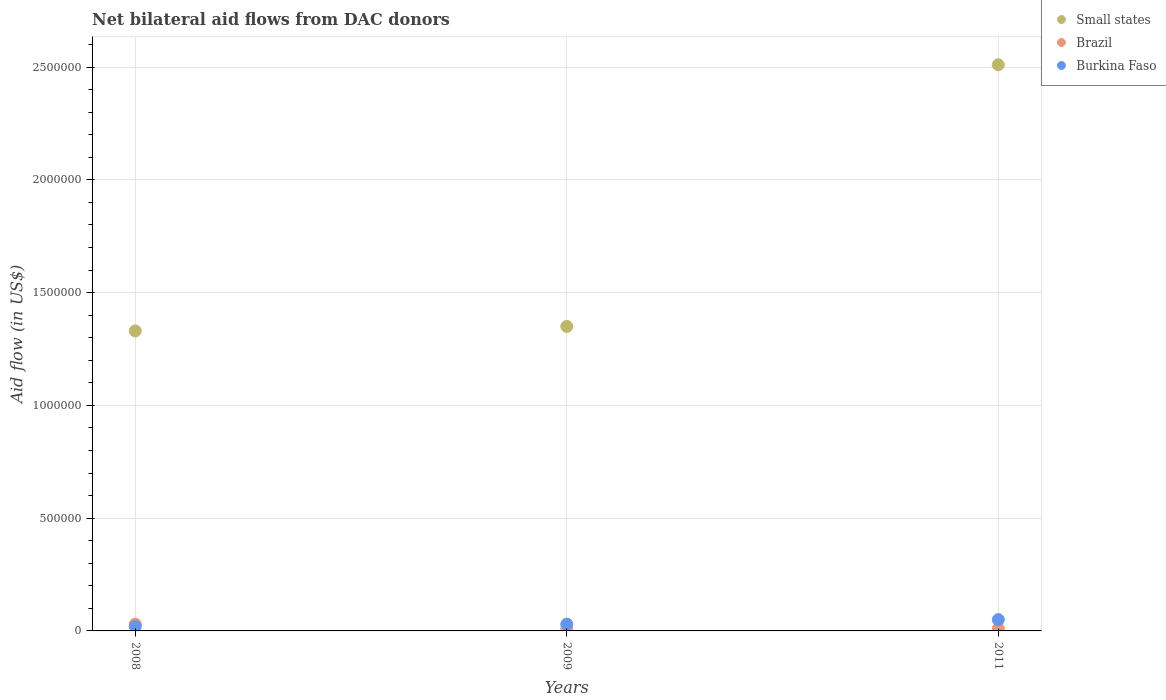Is the number of dotlines equal to the number of legend labels?
Your answer should be compact. Yes. What is the average net bilateral aid flow in Burkina Faso per year?
Your response must be concise. 3.33e+04. In the year 2011, what is the difference between the net bilateral aid flow in Burkina Faso and net bilateral aid flow in Brazil?
Your answer should be very brief. 4.00e+04. In how many years, is the net bilateral aid flow in Brazil greater than 1400000 US$?
Provide a succinct answer. 0. What is the difference between the highest and the lowest net bilateral aid flow in Burkina Faso?
Your answer should be compact. 3.00e+04. Is the sum of the net bilateral aid flow in Burkina Faso in 2008 and 2009 greater than the maximum net bilateral aid flow in Brazil across all years?
Keep it short and to the point. Yes. Is it the case that in every year, the sum of the net bilateral aid flow in Small states and net bilateral aid flow in Burkina Faso  is greater than the net bilateral aid flow in Brazil?
Provide a short and direct response. Yes. Is the net bilateral aid flow in Burkina Faso strictly greater than the net bilateral aid flow in Brazil over the years?
Your answer should be very brief. No. Does the graph contain any zero values?
Your answer should be very brief. No. Does the graph contain grids?
Provide a short and direct response. Yes. Where does the legend appear in the graph?
Ensure brevity in your answer.  Top right. How many legend labels are there?
Provide a short and direct response. 3. How are the legend labels stacked?
Offer a terse response. Vertical. What is the title of the graph?
Provide a succinct answer. Net bilateral aid flows from DAC donors. What is the label or title of the X-axis?
Your answer should be very brief. Years. What is the label or title of the Y-axis?
Keep it short and to the point. Aid flow (in US$). What is the Aid flow (in US$) in Small states in 2008?
Give a very brief answer. 1.33e+06. What is the Aid flow (in US$) of Brazil in 2008?
Offer a terse response. 3.00e+04. What is the Aid flow (in US$) in Burkina Faso in 2008?
Your response must be concise. 2.00e+04. What is the Aid flow (in US$) of Small states in 2009?
Give a very brief answer. 1.35e+06. What is the Aid flow (in US$) of Small states in 2011?
Ensure brevity in your answer.  2.51e+06. What is the Aid flow (in US$) in Brazil in 2011?
Offer a terse response. 10000. What is the Aid flow (in US$) of Burkina Faso in 2011?
Your response must be concise. 5.00e+04. Across all years, what is the maximum Aid flow (in US$) of Small states?
Provide a succinct answer. 2.51e+06. Across all years, what is the maximum Aid flow (in US$) of Brazil?
Your answer should be compact. 3.00e+04. Across all years, what is the maximum Aid flow (in US$) of Burkina Faso?
Keep it short and to the point. 5.00e+04. Across all years, what is the minimum Aid flow (in US$) in Small states?
Provide a short and direct response. 1.33e+06. Across all years, what is the minimum Aid flow (in US$) of Brazil?
Keep it short and to the point. 10000. Across all years, what is the minimum Aid flow (in US$) in Burkina Faso?
Provide a succinct answer. 2.00e+04. What is the total Aid flow (in US$) of Small states in the graph?
Ensure brevity in your answer.  5.19e+06. What is the total Aid flow (in US$) in Brazil in the graph?
Give a very brief answer. 5.00e+04. What is the total Aid flow (in US$) of Burkina Faso in the graph?
Your response must be concise. 1.00e+05. What is the difference between the Aid flow (in US$) in Small states in 2008 and that in 2009?
Offer a very short reply. -2.00e+04. What is the difference between the Aid flow (in US$) of Brazil in 2008 and that in 2009?
Your response must be concise. 2.00e+04. What is the difference between the Aid flow (in US$) in Burkina Faso in 2008 and that in 2009?
Your response must be concise. -10000. What is the difference between the Aid flow (in US$) in Small states in 2008 and that in 2011?
Provide a succinct answer. -1.18e+06. What is the difference between the Aid flow (in US$) of Brazil in 2008 and that in 2011?
Your answer should be compact. 2.00e+04. What is the difference between the Aid flow (in US$) in Small states in 2009 and that in 2011?
Provide a succinct answer. -1.16e+06. What is the difference between the Aid flow (in US$) of Burkina Faso in 2009 and that in 2011?
Your answer should be very brief. -2.00e+04. What is the difference between the Aid flow (in US$) in Small states in 2008 and the Aid flow (in US$) in Brazil in 2009?
Give a very brief answer. 1.32e+06. What is the difference between the Aid flow (in US$) of Small states in 2008 and the Aid flow (in US$) of Burkina Faso in 2009?
Ensure brevity in your answer.  1.30e+06. What is the difference between the Aid flow (in US$) in Small states in 2008 and the Aid flow (in US$) in Brazil in 2011?
Offer a terse response. 1.32e+06. What is the difference between the Aid flow (in US$) in Small states in 2008 and the Aid flow (in US$) in Burkina Faso in 2011?
Offer a very short reply. 1.28e+06. What is the difference between the Aid flow (in US$) of Small states in 2009 and the Aid flow (in US$) of Brazil in 2011?
Offer a very short reply. 1.34e+06. What is the difference between the Aid flow (in US$) in Small states in 2009 and the Aid flow (in US$) in Burkina Faso in 2011?
Ensure brevity in your answer.  1.30e+06. What is the average Aid flow (in US$) in Small states per year?
Ensure brevity in your answer.  1.73e+06. What is the average Aid flow (in US$) in Brazil per year?
Your answer should be compact. 1.67e+04. What is the average Aid flow (in US$) of Burkina Faso per year?
Offer a terse response. 3.33e+04. In the year 2008, what is the difference between the Aid flow (in US$) in Small states and Aid flow (in US$) in Brazil?
Your answer should be compact. 1.30e+06. In the year 2008, what is the difference between the Aid flow (in US$) of Small states and Aid flow (in US$) of Burkina Faso?
Ensure brevity in your answer.  1.31e+06. In the year 2008, what is the difference between the Aid flow (in US$) of Brazil and Aid flow (in US$) of Burkina Faso?
Keep it short and to the point. 10000. In the year 2009, what is the difference between the Aid flow (in US$) in Small states and Aid flow (in US$) in Brazil?
Offer a terse response. 1.34e+06. In the year 2009, what is the difference between the Aid flow (in US$) of Small states and Aid flow (in US$) of Burkina Faso?
Offer a very short reply. 1.32e+06. In the year 2009, what is the difference between the Aid flow (in US$) in Brazil and Aid flow (in US$) in Burkina Faso?
Offer a very short reply. -2.00e+04. In the year 2011, what is the difference between the Aid flow (in US$) of Small states and Aid flow (in US$) of Brazil?
Provide a short and direct response. 2.50e+06. In the year 2011, what is the difference between the Aid flow (in US$) in Small states and Aid flow (in US$) in Burkina Faso?
Give a very brief answer. 2.46e+06. In the year 2011, what is the difference between the Aid flow (in US$) in Brazil and Aid flow (in US$) in Burkina Faso?
Your answer should be compact. -4.00e+04. What is the ratio of the Aid flow (in US$) of Small states in 2008 to that in 2009?
Make the answer very short. 0.99. What is the ratio of the Aid flow (in US$) of Brazil in 2008 to that in 2009?
Keep it short and to the point. 3. What is the ratio of the Aid flow (in US$) in Small states in 2008 to that in 2011?
Provide a short and direct response. 0.53. What is the ratio of the Aid flow (in US$) of Brazil in 2008 to that in 2011?
Your response must be concise. 3. What is the ratio of the Aid flow (in US$) in Small states in 2009 to that in 2011?
Your response must be concise. 0.54. What is the ratio of the Aid flow (in US$) in Brazil in 2009 to that in 2011?
Provide a succinct answer. 1. What is the ratio of the Aid flow (in US$) of Burkina Faso in 2009 to that in 2011?
Offer a terse response. 0.6. What is the difference between the highest and the second highest Aid flow (in US$) of Small states?
Your answer should be very brief. 1.16e+06. What is the difference between the highest and the lowest Aid flow (in US$) in Small states?
Offer a very short reply. 1.18e+06. What is the difference between the highest and the lowest Aid flow (in US$) in Brazil?
Provide a short and direct response. 2.00e+04. 